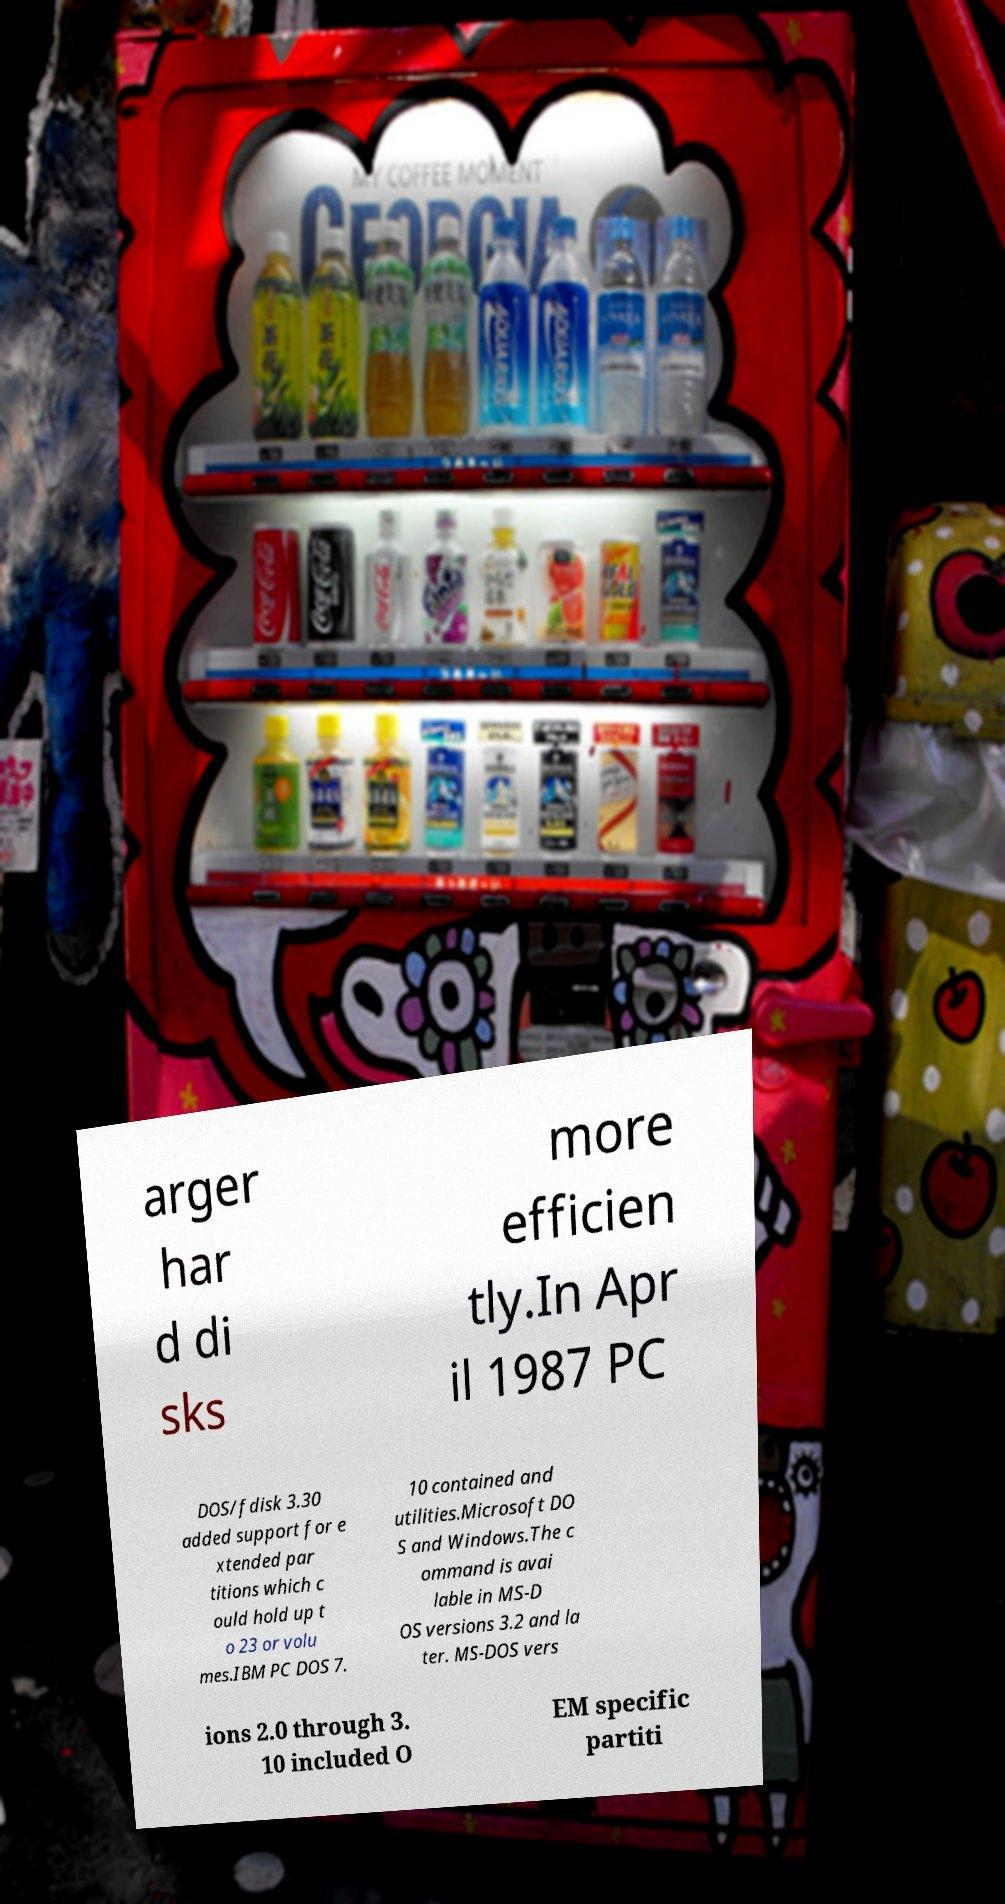Could you assist in decoding the text presented in this image and type it out clearly? arger har d di sks more efficien tly.In Apr il 1987 PC DOS/fdisk 3.30 added support for e xtended par titions which c ould hold up t o 23 or volu mes.IBM PC DOS 7. 10 contained and utilities.Microsoft DO S and Windows.The c ommand is avai lable in MS-D OS versions 3.2 and la ter. MS-DOS vers ions 2.0 through 3. 10 included O EM specific partiti 